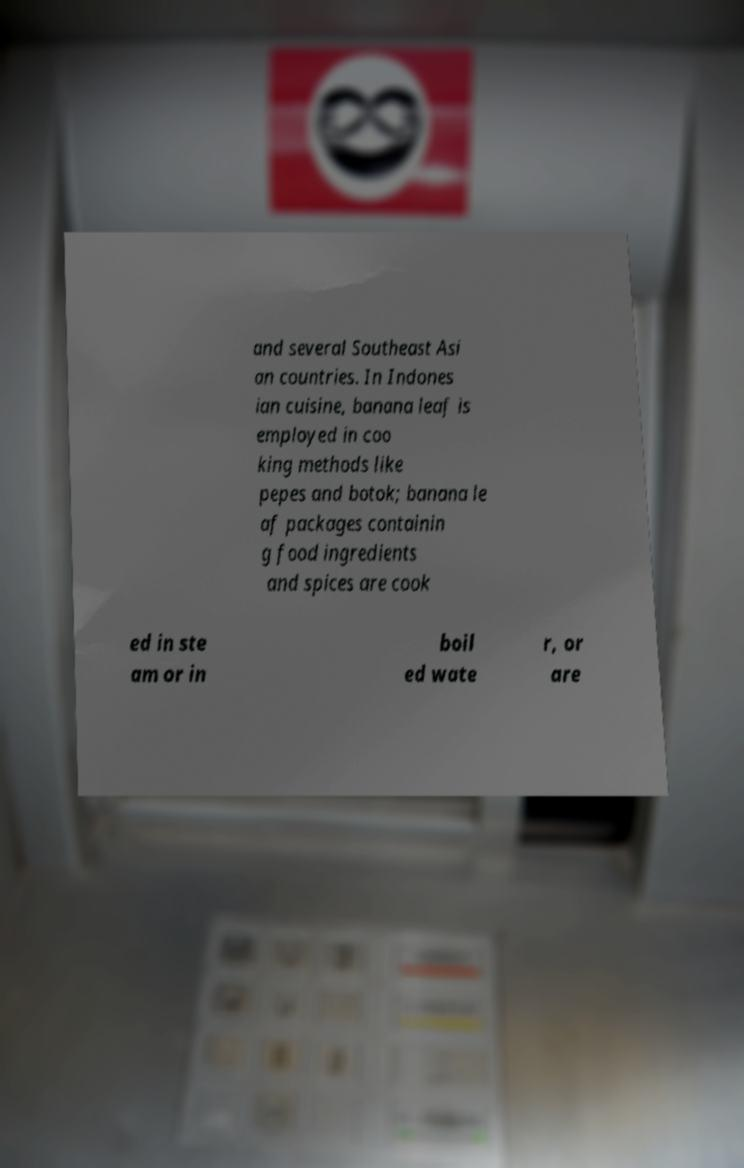Could you assist in decoding the text presented in this image and type it out clearly? and several Southeast Asi an countries. In Indones ian cuisine, banana leaf is employed in coo king methods like pepes and botok; banana le af packages containin g food ingredients and spices are cook ed in ste am or in boil ed wate r, or are 